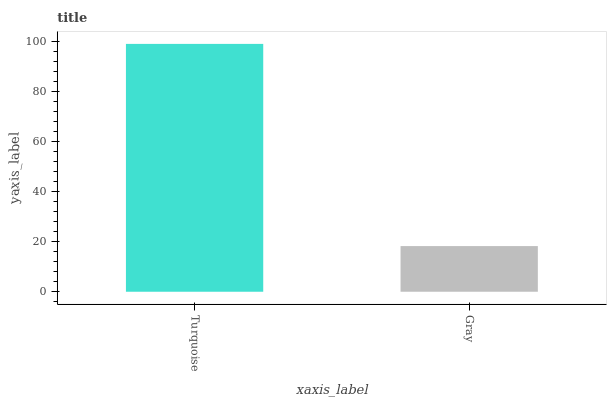Is Gray the minimum?
Answer yes or no. Yes. Is Turquoise the maximum?
Answer yes or no. Yes. Is Gray the maximum?
Answer yes or no. No. Is Turquoise greater than Gray?
Answer yes or no. Yes. Is Gray less than Turquoise?
Answer yes or no. Yes. Is Gray greater than Turquoise?
Answer yes or no. No. Is Turquoise less than Gray?
Answer yes or no. No. Is Turquoise the high median?
Answer yes or no. Yes. Is Gray the low median?
Answer yes or no. Yes. Is Gray the high median?
Answer yes or no. No. Is Turquoise the low median?
Answer yes or no. No. 